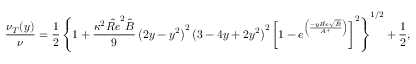<formula> <loc_0><loc_0><loc_500><loc_500>\frac { \nu _ { T } ( y ) } { \nu } = \frac { 1 } { 2 } \left \{ 1 + \frac { \kappa ^ { 2 } { \hat { R e } } ^ { 2 } \hat { B } } { 9 } \left ( 2 y - y ^ { 2 } \right ) ^ { 2 } \left ( 3 - 4 y + 2 y ^ { 2 } \right ) ^ { 2 } \left [ 1 - e ^ { \left ( \frac { - y \hat { R e } \sqrt { \hat { B } } } { A ^ { + } } \right ) } \right ] ^ { 2 } \right \} ^ { 1 / 2 } + \frac { 1 } { 2 } ,</formula> 